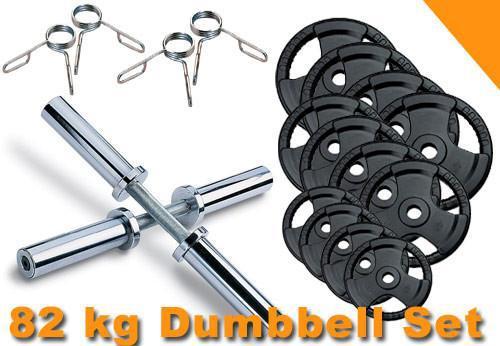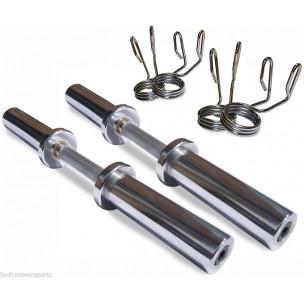The first image is the image on the left, the second image is the image on the right. Given the left and right images, does the statement "There are a total of four dumbbell bars with only two having weight on them." hold true? Answer yes or no. No. The first image is the image on the left, the second image is the image on the right. Evaluate the accuracy of this statement regarding the images: "One image includes at least 12 round black weights and two bars, and the other image features two chrome bars displayed parallel to each other, and a pair of wire clamp shapes next to them.". Is it true? Answer yes or no. Yes. 